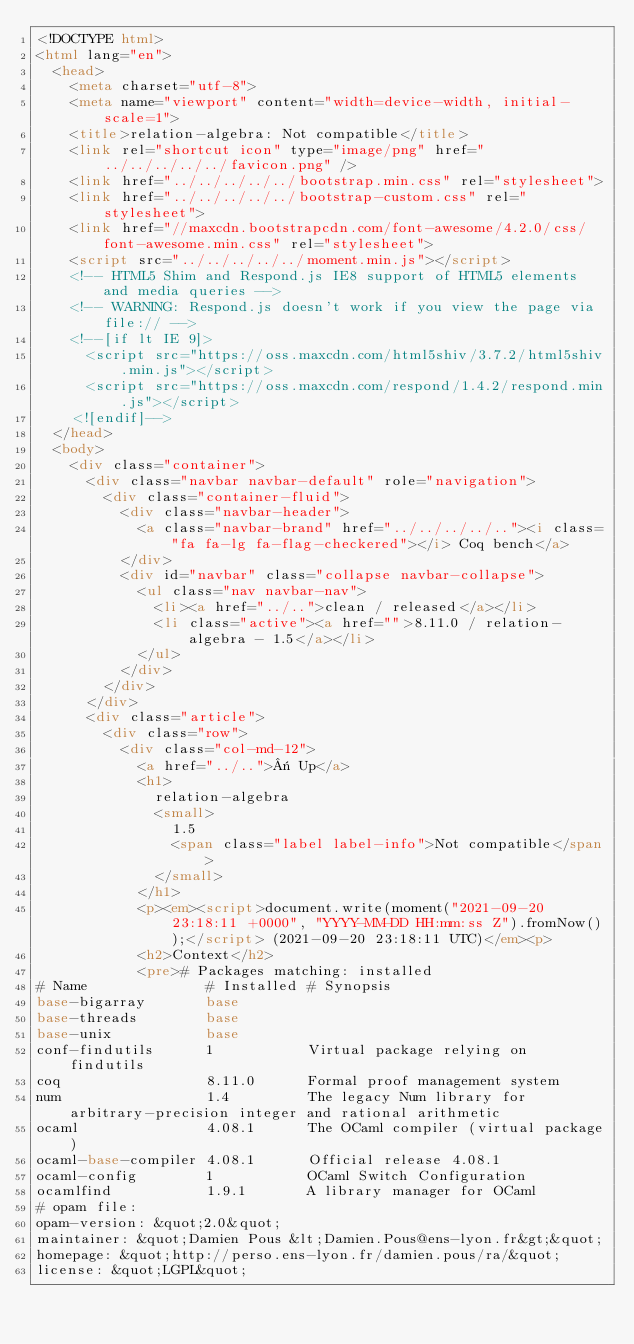<code> <loc_0><loc_0><loc_500><loc_500><_HTML_><!DOCTYPE html>
<html lang="en">
  <head>
    <meta charset="utf-8">
    <meta name="viewport" content="width=device-width, initial-scale=1">
    <title>relation-algebra: Not compatible</title>
    <link rel="shortcut icon" type="image/png" href="../../../../../favicon.png" />
    <link href="../../../../../bootstrap.min.css" rel="stylesheet">
    <link href="../../../../../bootstrap-custom.css" rel="stylesheet">
    <link href="//maxcdn.bootstrapcdn.com/font-awesome/4.2.0/css/font-awesome.min.css" rel="stylesheet">
    <script src="../../../../../moment.min.js"></script>
    <!-- HTML5 Shim and Respond.js IE8 support of HTML5 elements and media queries -->
    <!-- WARNING: Respond.js doesn't work if you view the page via file:// -->
    <!--[if lt IE 9]>
      <script src="https://oss.maxcdn.com/html5shiv/3.7.2/html5shiv.min.js"></script>
      <script src="https://oss.maxcdn.com/respond/1.4.2/respond.min.js"></script>
    <![endif]-->
  </head>
  <body>
    <div class="container">
      <div class="navbar navbar-default" role="navigation">
        <div class="container-fluid">
          <div class="navbar-header">
            <a class="navbar-brand" href="../../../../.."><i class="fa fa-lg fa-flag-checkered"></i> Coq bench</a>
          </div>
          <div id="navbar" class="collapse navbar-collapse">
            <ul class="nav navbar-nav">
              <li><a href="../..">clean / released</a></li>
              <li class="active"><a href="">8.11.0 / relation-algebra - 1.5</a></li>
            </ul>
          </div>
        </div>
      </div>
      <div class="article">
        <div class="row">
          <div class="col-md-12">
            <a href="../..">« Up</a>
            <h1>
              relation-algebra
              <small>
                1.5
                <span class="label label-info">Not compatible</span>
              </small>
            </h1>
            <p><em><script>document.write(moment("2021-09-20 23:18:11 +0000", "YYYY-MM-DD HH:mm:ss Z").fromNow());</script> (2021-09-20 23:18:11 UTC)</em><p>
            <h2>Context</h2>
            <pre># Packages matching: installed
# Name              # Installed # Synopsis
base-bigarray       base
base-threads        base
base-unix           base
conf-findutils      1           Virtual package relying on findutils
coq                 8.11.0      Formal proof management system
num                 1.4         The legacy Num library for arbitrary-precision integer and rational arithmetic
ocaml               4.08.1      The OCaml compiler (virtual package)
ocaml-base-compiler 4.08.1      Official release 4.08.1
ocaml-config        1           OCaml Switch Configuration
ocamlfind           1.9.1       A library manager for OCaml
# opam file:
opam-version: &quot;2.0&quot;
maintainer: &quot;Damien Pous &lt;Damien.Pous@ens-lyon.fr&gt;&quot;
homepage: &quot;http://perso.ens-lyon.fr/damien.pous/ra/&quot;
license: &quot;LGPL&quot;</code> 